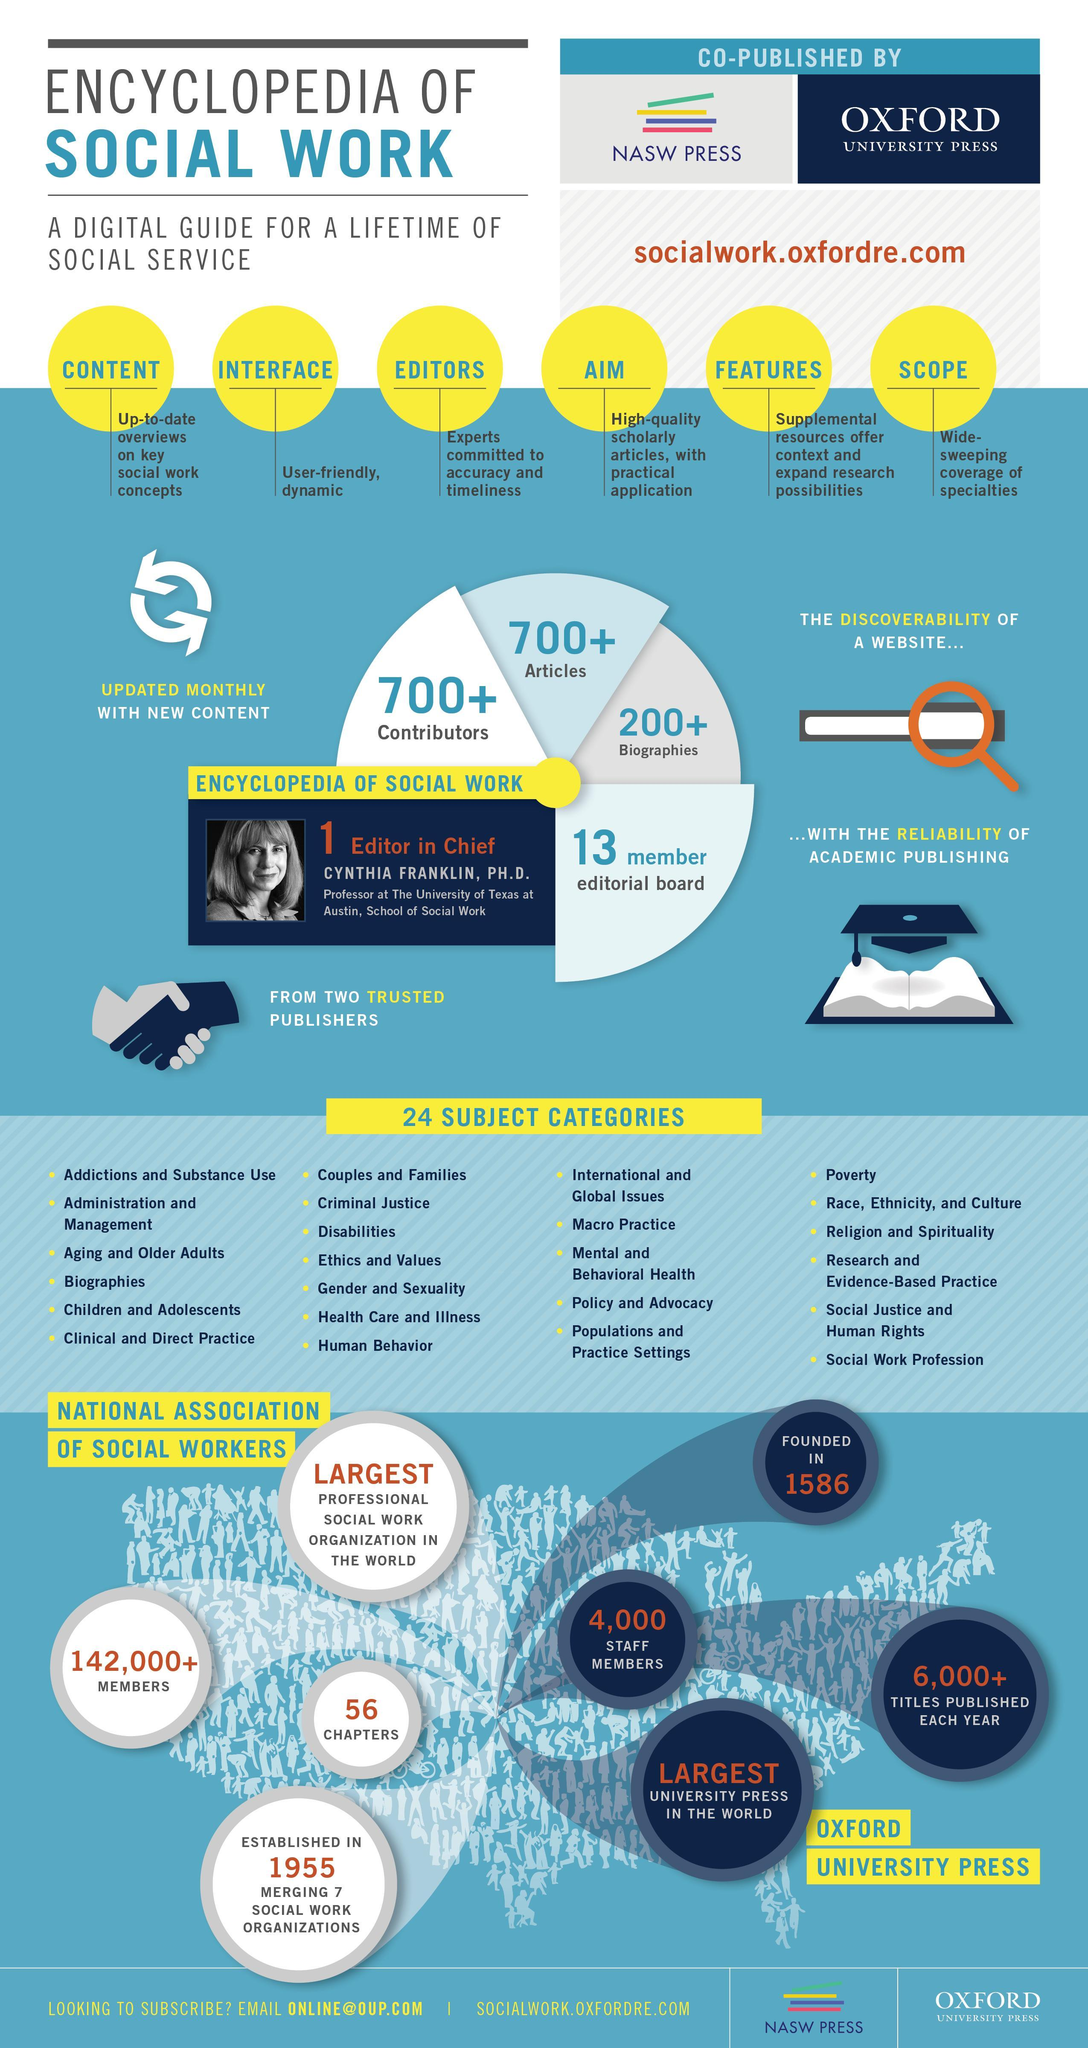What is the number of staff Oxford University Press has?
Answer the question with a short phrase. 4,000 What is the number of contributors and articles in the encyclopedia of Social work? 700+ How many members does national association of Social workers have, 142,000+, 4,000, or 6000+? 142,000+ When was Oxford University Press established, 1955, 1586, or 1856? 1586 